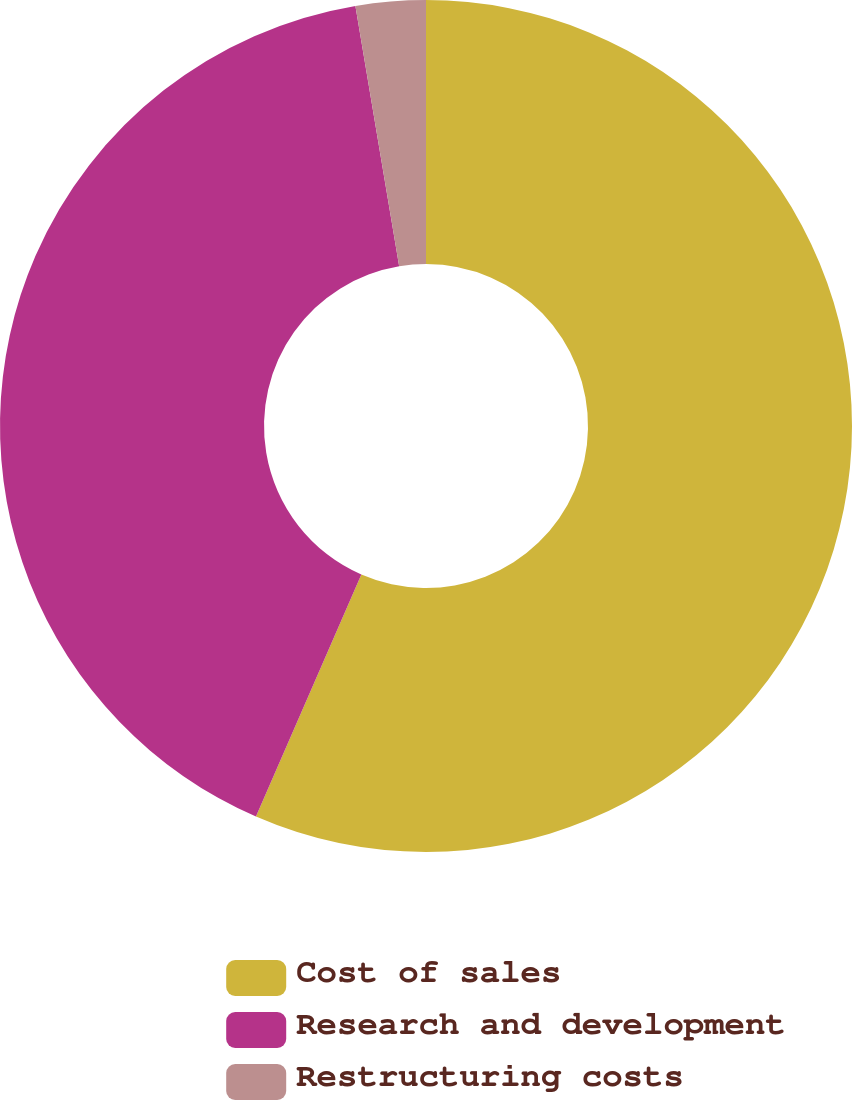<chart> <loc_0><loc_0><loc_500><loc_500><pie_chart><fcel>Cost of sales<fcel>Research and development<fcel>Restructuring costs<nl><fcel>56.54%<fcel>40.82%<fcel>2.65%<nl></chart> 